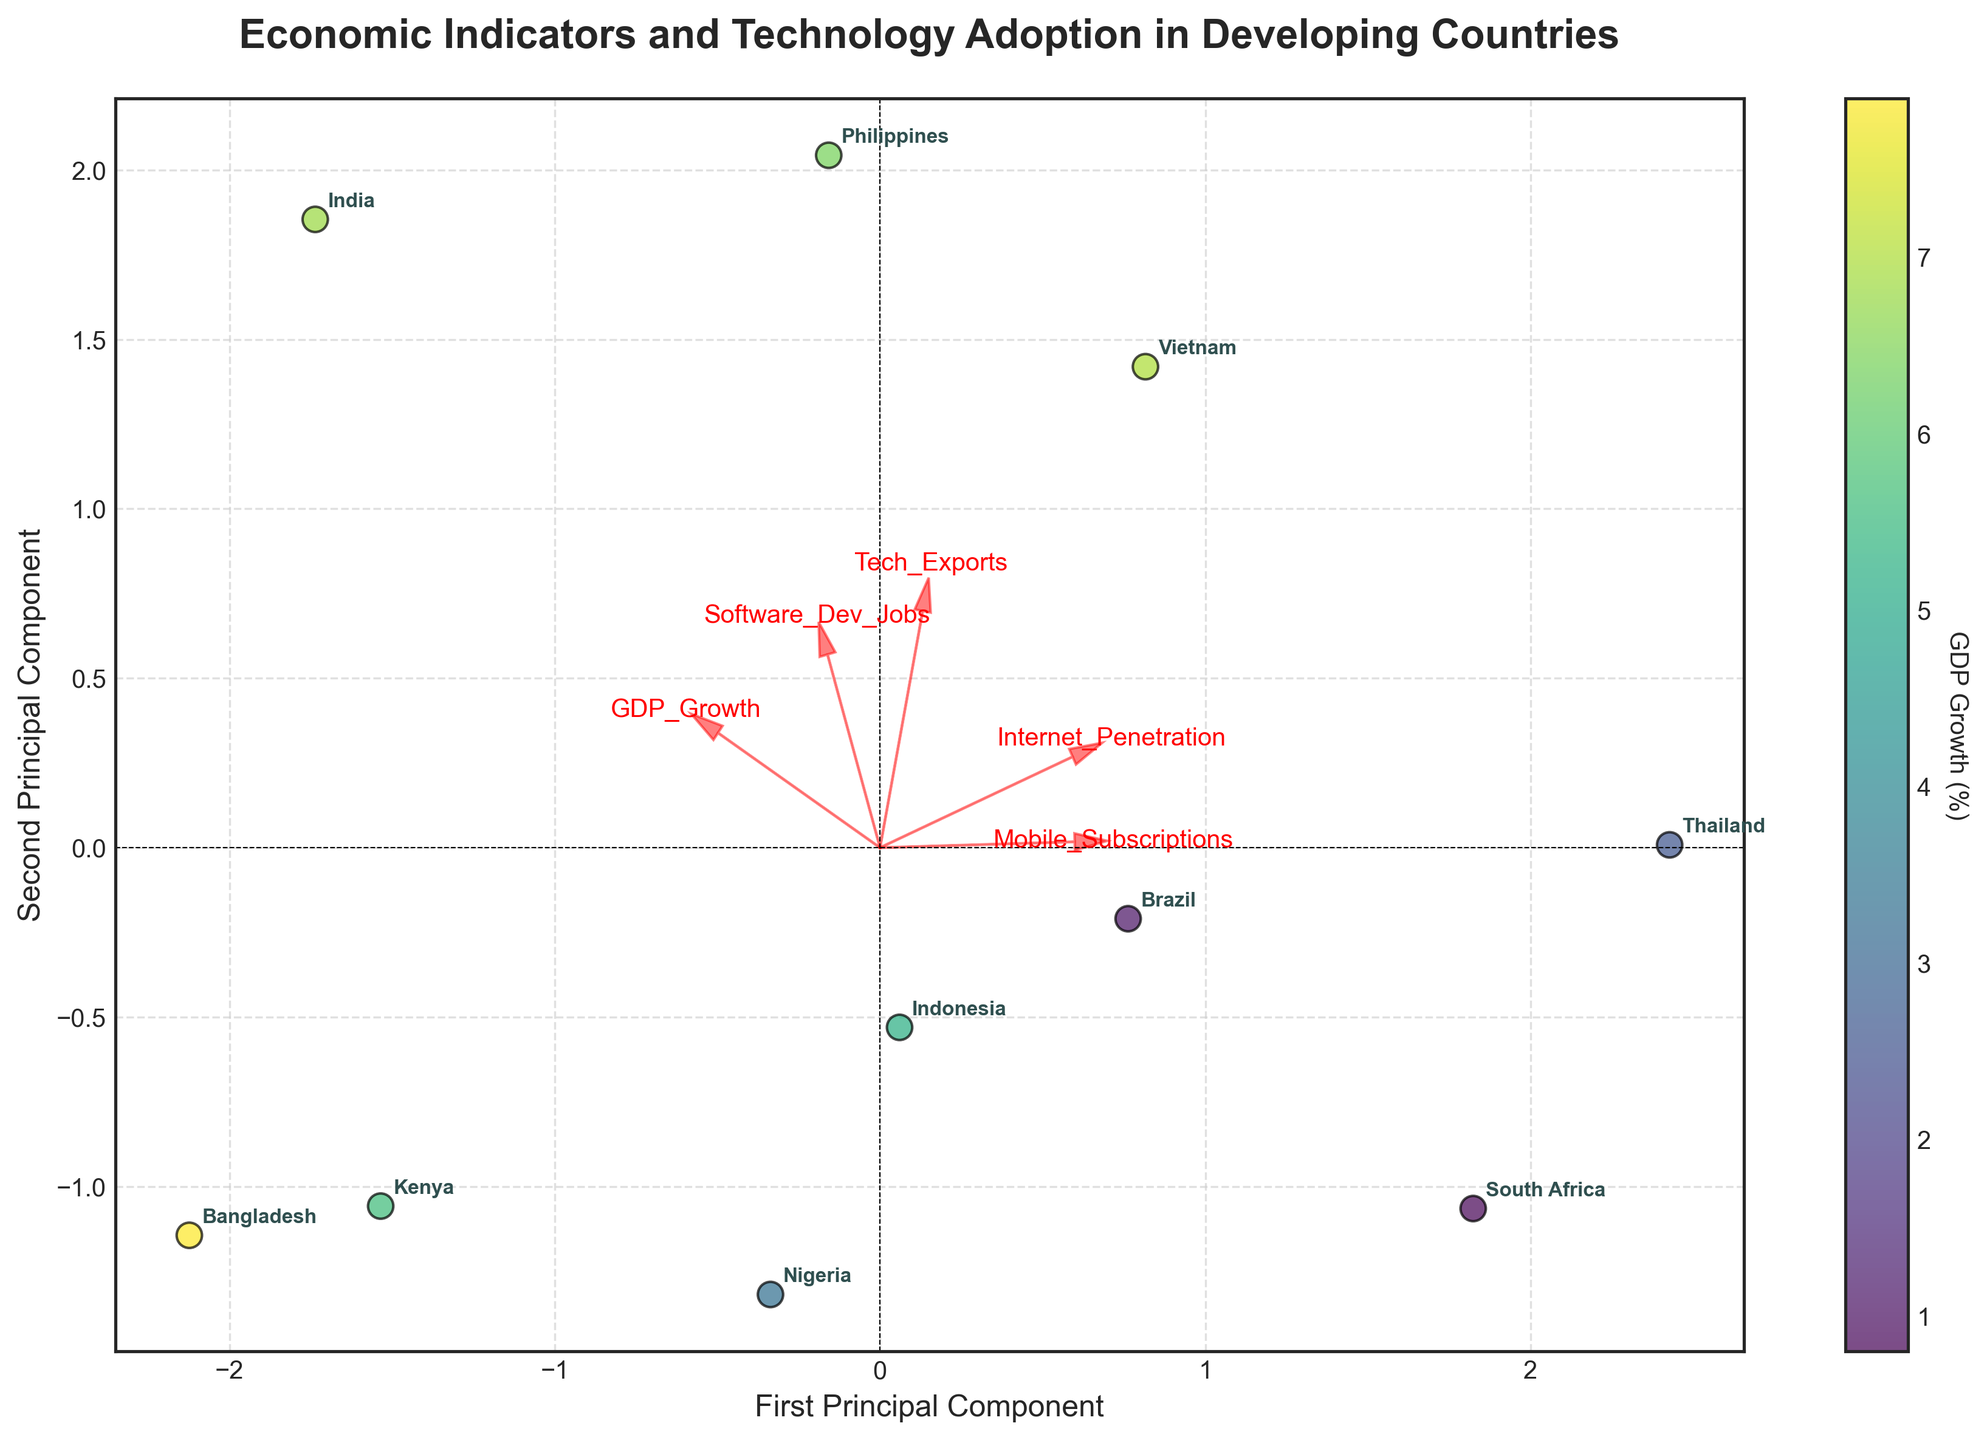What are the two axes labeled? The two axes are labeled "First Principal Component" and "Second Principal Component," which are the principal components resulting from the PCA analysis of the economic and technology adoption indicators.
Answer: First Principal Component, Second Principal Component Which country has the highest GDP growth rate and where is it located on the biplot? The country with the highest GDP growth rate is Bangladesh. Its position on the biplot can be identified by finding the point with a higher intensity in the color corresponding to the highest value on the color bar for GDP Growth, and it is located in the lower-central left area.
Answer: Bangladesh, lower-central left area Which feature vector is the longest and what does it represent? The feature vector for "Mobile Subscriptions" is the longest, which indicates it has the highest loading on the first principal component, showing that it contributes significantly to the variance in the dataset.
Answer: Mobile Subscriptions Which countries cluster closely together and what might this imply? Brazil and South Africa cluster closely together on the biplot. This implies that these two countries have similar values in terms of the economic and technology adoption indicators considered in the PCA analysis.
Answer: Brazil, South Africa, similar indicators Which country has the highest internet penetration but relatively low GDP growth? The country with the highest internet penetration is Vietnam, which is indicated by its position aligned with the "Internet Penetration" vector. Although it has high internet penetration, Vietnam does not have the highest GDP growth compared to Bangladesh.
Answer: Vietnam Consider the features "Tech Exports" and "Software Dev Jobs." Which feature lies more along the first principal component direction? The feature "Tech Exports" lies more along the direction of the first principal component as indicated by its direction and relative length compared to "Software Dev Jobs," which has a smaller projection along the first principal component.
Answer: Tech Exports Are there any countries with both high "Mobile Subscriptions" and "Internet Penetration"? The Philippines shows both high "Mobile Subscriptions" and "Internet Penetration," as it is positioned along the vectors pointing to these features, indicating a strong correlation with both.
Answer: Philippines Which country's position on the biplot signifies the highest combination of "Tech Exports" and "Software Dev Jobs"? The Philippines' position indicates the highest combination of "Tech Exports" and "Software Dev Jobs," as it lies further out along the vectors for these features compared to other countries.
Answer: Philippines 